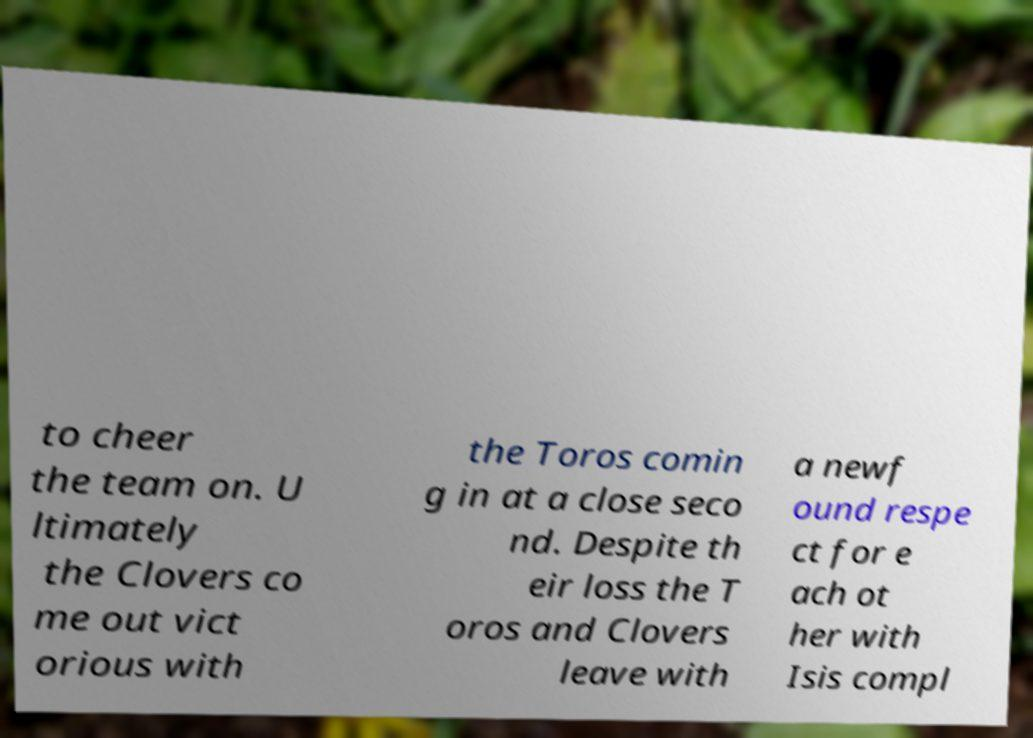Please identify and transcribe the text found in this image. to cheer the team on. U ltimately the Clovers co me out vict orious with the Toros comin g in at a close seco nd. Despite th eir loss the T oros and Clovers leave with a newf ound respe ct for e ach ot her with Isis compl 